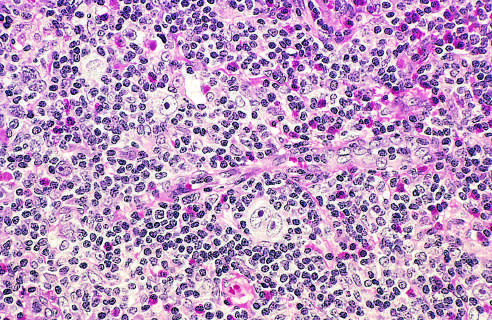s a diagnostic, binucleate reed-sternberg cell surrounded by eosinophils, lymphocytes, and histiocytes?
Answer the question using a single word or phrase. Yes 